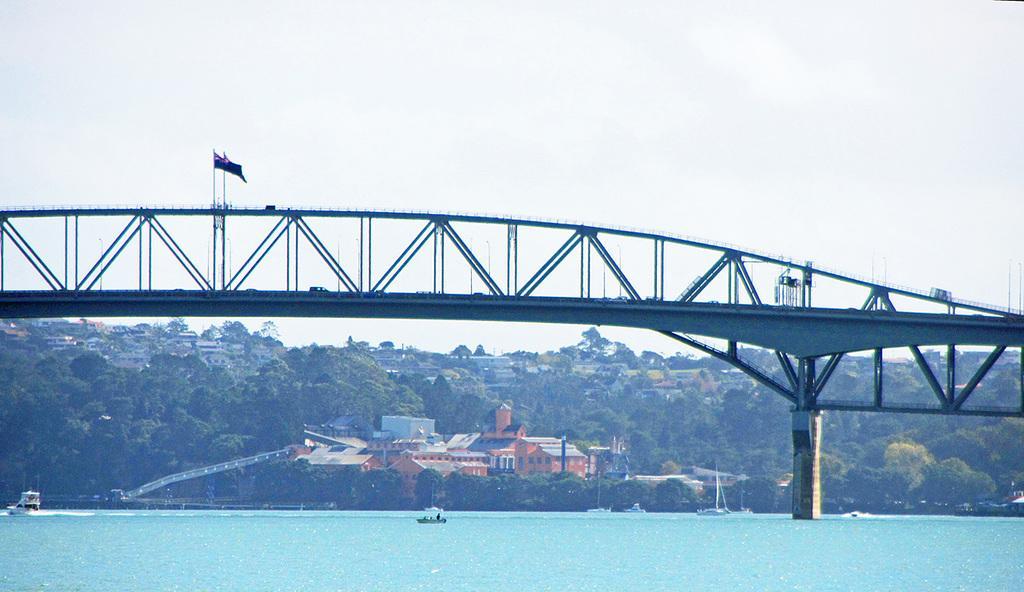How would you summarize this image in a sentence or two? In this image I can see at the bottom there is a boat in the water, in the middle there are buildings and there is a very big bridge. At the top it is the cloudy sky. 